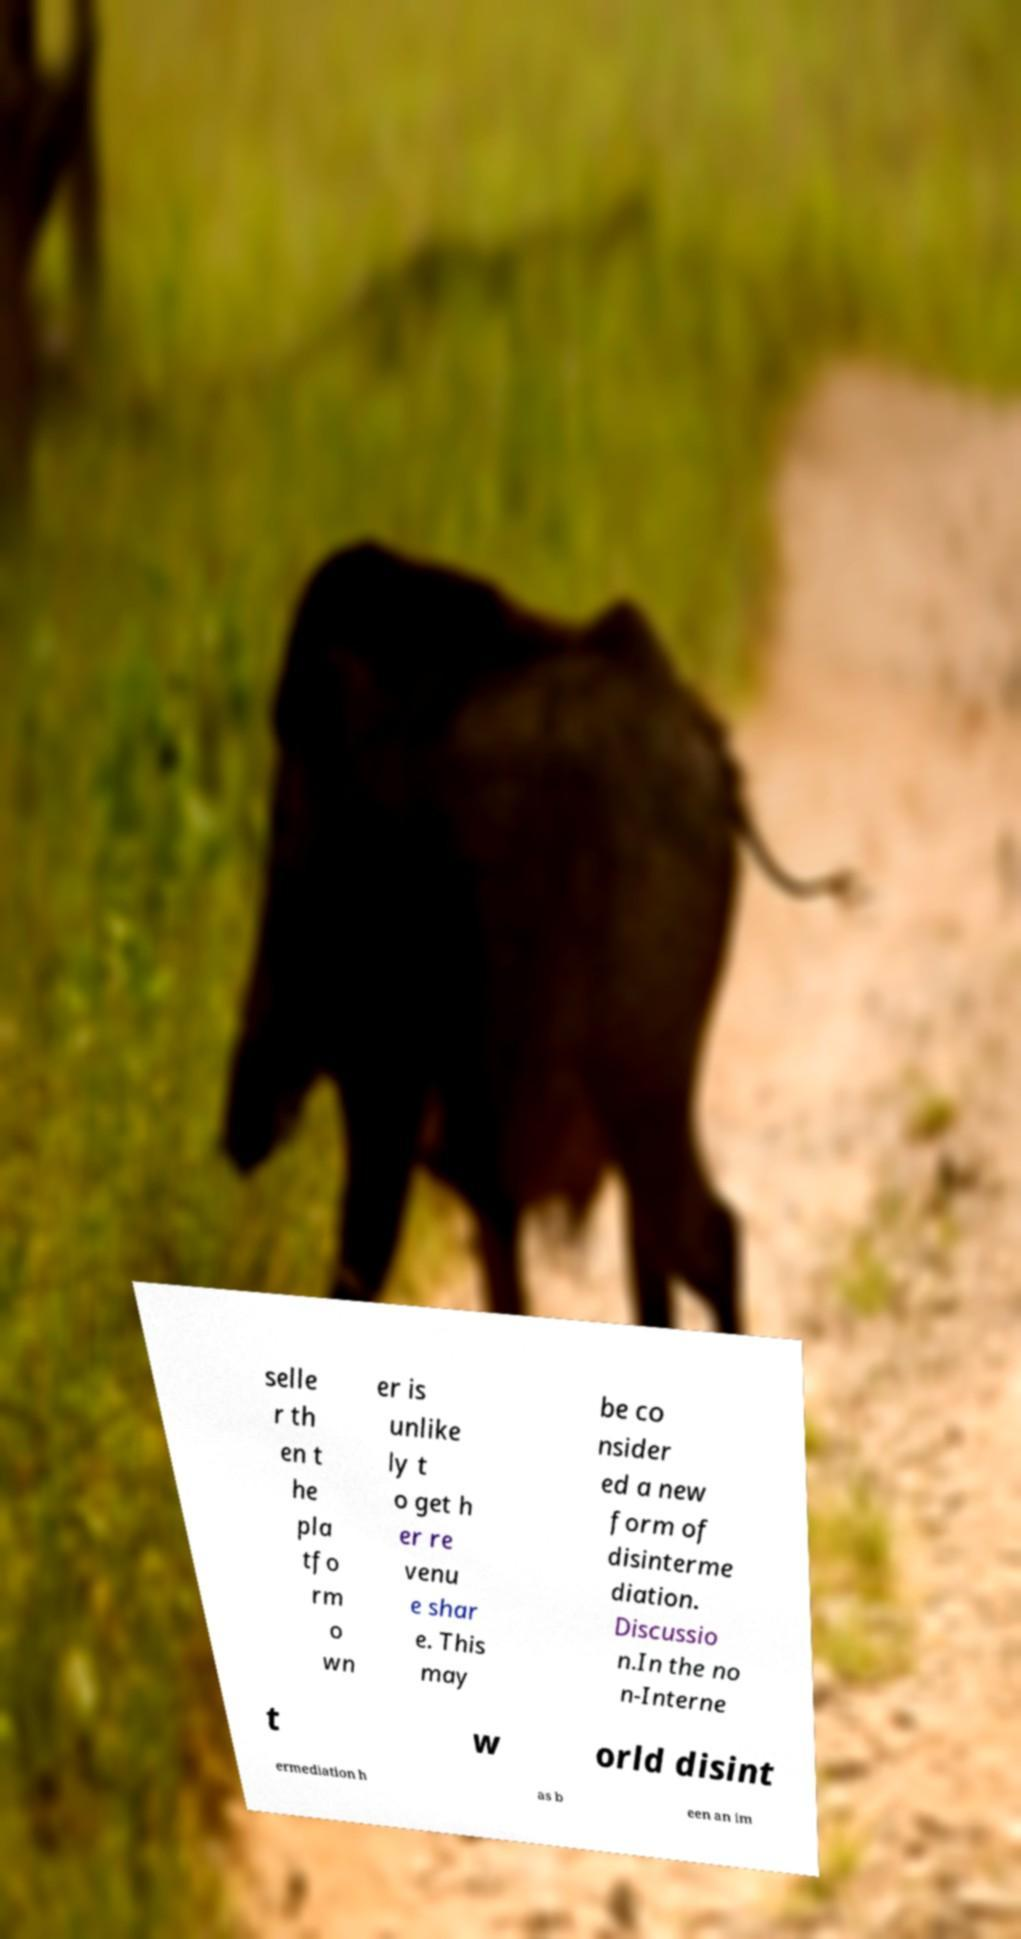Please read and relay the text visible in this image. What does it say? selle r th en t he pla tfo rm o wn er is unlike ly t o get h er re venu e shar e. This may be co nsider ed a new form of disinterme diation. Discussio n.In the no n-Interne t w orld disint ermediation h as b een an im 